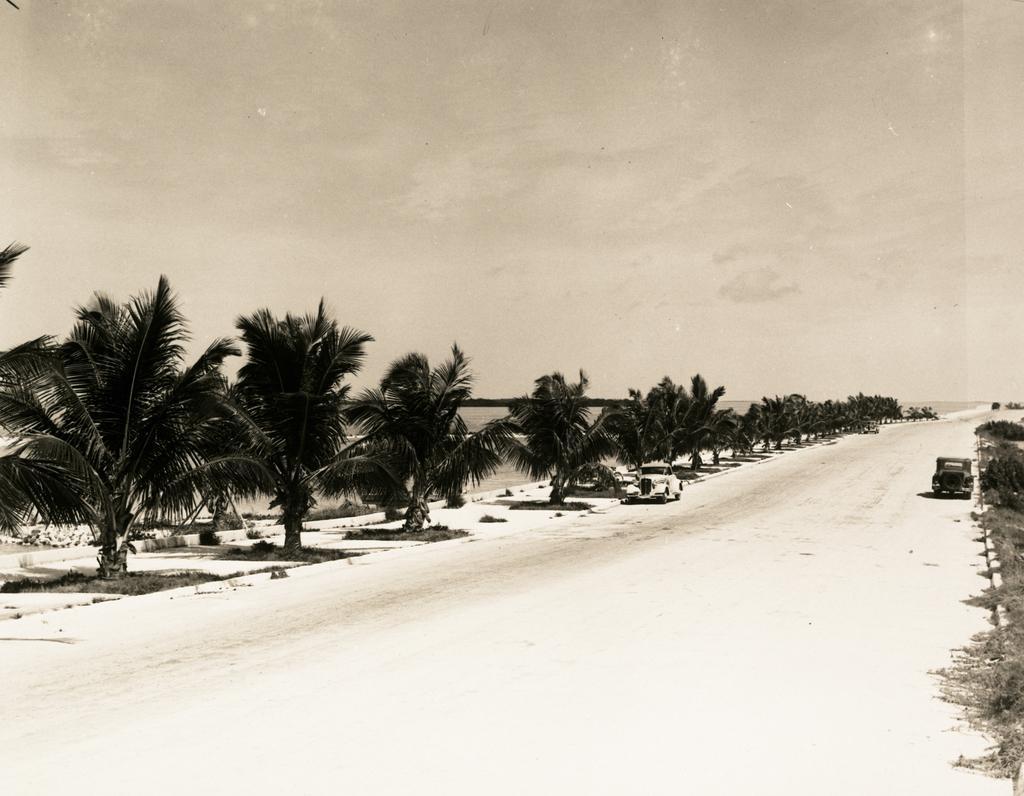Please provide a concise description of this image. In this image, we can see plants, trees and vehicles on the road. In the background, we can see water and the sky. 